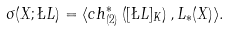<formula> <loc_0><loc_0><loc_500><loc_500>\sigma ( X ; \L L ) = \langle c h ^ { * } _ { ( 2 ) } \left ( [ \L L ] _ { K } \right ) , L _ { * } ( X ) \rangle .</formula> 